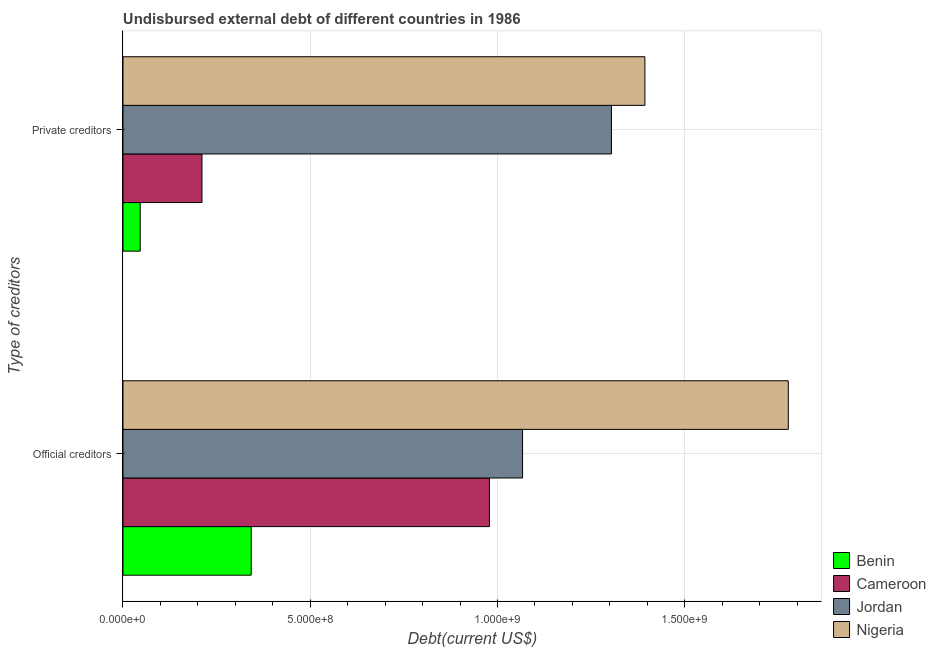How many groups of bars are there?
Your answer should be compact. 2. Are the number of bars per tick equal to the number of legend labels?
Offer a very short reply. Yes. Are the number of bars on each tick of the Y-axis equal?
Make the answer very short. Yes. How many bars are there on the 2nd tick from the bottom?
Make the answer very short. 4. What is the label of the 1st group of bars from the top?
Give a very brief answer. Private creditors. What is the undisbursed external debt of private creditors in Benin?
Keep it short and to the point. 4.60e+07. Across all countries, what is the maximum undisbursed external debt of private creditors?
Your answer should be very brief. 1.39e+09. Across all countries, what is the minimum undisbursed external debt of official creditors?
Your response must be concise. 3.42e+08. In which country was the undisbursed external debt of private creditors maximum?
Keep it short and to the point. Nigeria. In which country was the undisbursed external debt of official creditors minimum?
Ensure brevity in your answer.  Benin. What is the total undisbursed external debt of official creditors in the graph?
Your answer should be compact. 4.16e+09. What is the difference between the undisbursed external debt of private creditors in Jordan and that in Cameroon?
Your answer should be compact. 1.09e+09. What is the difference between the undisbursed external debt of official creditors in Benin and the undisbursed external debt of private creditors in Cameroon?
Keep it short and to the point. 1.31e+08. What is the average undisbursed external debt of official creditors per country?
Offer a very short reply. 1.04e+09. What is the difference between the undisbursed external debt of private creditors and undisbursed external debt of official creditors in Cameroon?
Keep it short and to the point. -7.67e+08. What is the ratio of the undisbursed external debt of private creditors in Cameroon to that in Nigeria?
Ensure brevity in your answer.  0.15. In how many countries, is the undisbursed external debt of private creditors greater than the average undisbursed external debt of private creditors taken over all countries?
Your response must be concise. 2. What does the 4th bar from the top in Official creditors represents?
Your response must be concise. Benin. What does the 1st bar from the bottom in Official creditors represents?
Make the answer very short. Benin. How many bars are there?
Ensure brevity in your answer.  8. How many countries are there in the graph?
Keep it short and to the point. 4. Are the values on the major ticks of X-axis written in scientific E-notation?
Your response must be concise. Yes. Does the graph contain any zero values?
Make the answer very short. No. How are the legend labels stacked?
Provide a short and direct response. Vertical. What is the title of the graph?
Make the answer very short. Undisbursed external debt of different countries in 1986. What is the label or title of the X-axis?
Offer a very short reply. Debt(current US$). What is the label or title of the Y-axis?
Give a very brief answer. Type of creditors. What is the Debt(current US$) in Benin in Official creditors?
Provide a short and direct response. 3.42e+08. What is the Debt(current US$) of Cameroon in Official creditors?
Provide a short and direct response. 9.78e+08. What is the Debt(current US$) of Jordan in Official creditors?
Provide a succinct answer. 1.07e+09. What is the Debt(current US$) of Nigeria in Official creditors?
Your response must be concise. 1.78e+09. What is the Debt(current US$) of Benin in Private creditors?
Offer a terse response. 4.60e+07. What is the Debt(current US$) in Cameroon in Private creditors?
Keep it short and to the point. 2.11e+08. What is the Debt(current US$) in Jordan in Private creditors?
Offer a very short reply. 1.30e+09. What is the Debt(current US$) of Nigeria in Private creditors?
Provide a succinct answer. 1.39e+09. Across all Type of creditors, what is the maximum Debt(current US$) of Benin?
Provide a succinct answer. 3.42e+08. Across all Type of creditors, what is the maximum Debt(current US$) in Cameroon?
Offer a very short reply. 9.78e+08. Across all Type of creditors, what is the maximum Debt(current US$) in Jordan?
Your answer should be compact. 1.30e+09. Across all Type of creditors, what is the maximum Debt(current US$) of Nigeria?
Provide a succinct answer. 1.78e+09. Across all Type of creditors, what is the minimum Debt(current US$) in Benin?
Provide a succinct answer. 4.60e+07. Across all Type of creditors, what is the minimum Debt(current US$) in Cameroon?
Provide a succinct answer. 2.11e+08. Across all Type of creditors, what is the minimum Debt(current US$) in Jordan?
Keep it short and to the point. 1.07e+09. Across all Type of creditors, what is the minimum Debt(current US$) in Nigeria?
Provide a succinct answer. 1.39e+09. What is the total Debt(current US$) of Benin in the graph?
Offer a very short reply. 3.88e+08. What is the total Debt(current US$) in Cameroon in the graph?
Offer a terse response. 1.19e+09. What is the total Debt(current US$) of Jordan in the graph?
Your answer should be very brief. 2.37e+09. What is the total Debt(current US$) in Nigeria in the graph?
Offer a terse response. 3.17e+09. What is the difference between the Debt(current US$) in Benin in Official creditors and that in Private creditors?
Provide a succinct answer. 2.96e+08. What is the difference between the Debt(current US$) in Cameroon in Official creditors and that in Private creditors?
Offer a very short reply. 7.67e+08. What is the difference between the Debt(current US$) of Jordan in Official creditors and that in Private creditors?
Your answer should be very brief. -2.37e+08. What is the difference between the Debt(current US$) in Nigeria in Official creditors and that in Private creditors?
Offer a very short reply. 3.83e+08. What is the difference between the Debt(current US$) of Benin in Official creditors and the Debt(current US$) of Cameroon in Private creditors?
Your answer should be very brief. 1.31e+08. What is the difference between the Debt(current US$) of Benin in Official creditors and the Debt(current US$) of Jordan in Private creditors?
Your answer should be very brief. -9.62e+08. What is the difference between the Debt(current US$) of Benin in Official creditors and the Debt(current US$) of Nigeria in Private creditors?
Your answer should be very brief. -1.05e+09. What is the difference between the Debt(current US$) in Cameroon in Official creditors and the Debt(current US$) in Jordan in Private creditors?
Your answer should be compact. -3.26e+08. What is the difference between the Debt(current US$) of Cameroon in Official creditors and the Debt(current US$) of Nigeria in Private creditors?
Your answer should be very brief. -4.15e+08. What is the difference between the Debt(current US$) of Jordan in Official creditors and the Debt(current US$) of Nigeria in Private creditors?
Your answer should be very brief. -3.27e+08. What is the average Debt(current US$) in Benin per Type of creditors?
Offer a very short reply. 1.94e+08. What is the average Debt(current US$) in Cameroon per Type of creditors?
Offer a terse response. 5.95e+08. What is the average Debt(current US$) of Jordan per Type of creditors?
Your answer should be very brief. 1.19e+09. What is the average Debt(current US$) in Nigeria per Type of creditors?
Make the answer very short. 1.58e+09. What is the difference between the Debt(current US$) of Benin and Debt(current US$) of Cameroon in Official creditors?
Your answer should be compact. -6.36e+08. What is the difference between the Debt(current US$) in Benin and Debt(current US$) in Jordan in Official creditors?
Provide a short and direct response. -7.24e+08. What is the difference between the Debt(current US$) in Benin and Debt(current US$) in Nigeria in Official creditors?
Your response must be concise. -1.43e+09. What is the difference between the Debt(current US$) of Cameroon and Debt(current US$) of Jordan in Official creditors?
Give a very brief answer. -8.84e+07. What is the difference between the Debt(current US$) in Cameroon and Debt(current US$) in Nigeria in Official creditors?
Offer a very short reply. -7.98e+08. What is the difference between the Debt(current US$) of Jordan and Debt(current US$) of Nigeria in Official creditors?
Offer a very short reply. -7.09e+08. What is the difference between the Debt(current US$) of Benin and Debt(current US$) of Cameroon in Private creditors?
Offer a terse response. -1.65e+08. What is the difference between the Debt(current US$) of Benin and Debt(current US$) of Jordan in Private creditors?
Provide a succinct answer. -1.26e+09. What is the difference between the Debt(current US$) of Benin and Debt(current US$) of Nigeria in Private creditors?
Your answer should be compact. -1.35e+09. What is the difference between the Debt(current US$) of Cameroon and Debt(current US$) of Jordan in Private creditors?
Offer a very short reply. -1.09e+09. What is the difference between the Debt(current US$) of Cameroon and Debt(current US$) of Nigeria in Private creditors?
Provide a short and direct response. -1.18e+09. What is the difference between the Debt(current US$) in Jordan and Debt(current US$) in Nigeria in Private creditors?
Give a very brief answer. -8.93e+07. What is the ratio of the Debt(current US$) of Benin in Official creditors to that in Private creditors?
Ensure brevity in your answer.  7.44. What is the ratio of the Debt(current US$) of Cameroon in Official creditors to that in Private creditors?
Your answer should be very brief. 4.64. What is the ratio of the Debt(current US$) of Jordan in Official creditors to that in Private creditors?
Ensure brevity in your answer.  0.82. What is the ratio of the Debt(current US$) of Nigeria in Official creditors to that in Private creditors?
Ensure brevity in your answer.  1.27. What is the difference between the highest and the second highest Debt(current US$) in Benin?
Your answer should be compact. 2.96e+08. What is the difference between the highest and the second highest Debt(current US$) of Cameroon?
Provide a succinct answer. 7.67e+08. What is the difference between the highest and the second highest Debt(current US$) in Jordan?
Your answer should be compact. 2.37e+08. What is the difference between the highest and the second highest Debt(current US$) of Nigeria?
Provide a short and direct response. 3.83e+08. What is the difference between the highest and the lowest Debt(current US$) in Benin?
Your answer should be very brief. 2.96e+08. What is the difference between the highest and the lowest Debt(current US$) of Cameroon?
Make the answer very short. 7.67e+08. What is the difference between the highest and the lowest Debt(current US$) in Jordan?
Make the answer very short. 2.37e+08. What is the difference between the highest and the lowest Debt(current US$) of Nigeria?
Your answer should be very brief. 3.83e+08. 